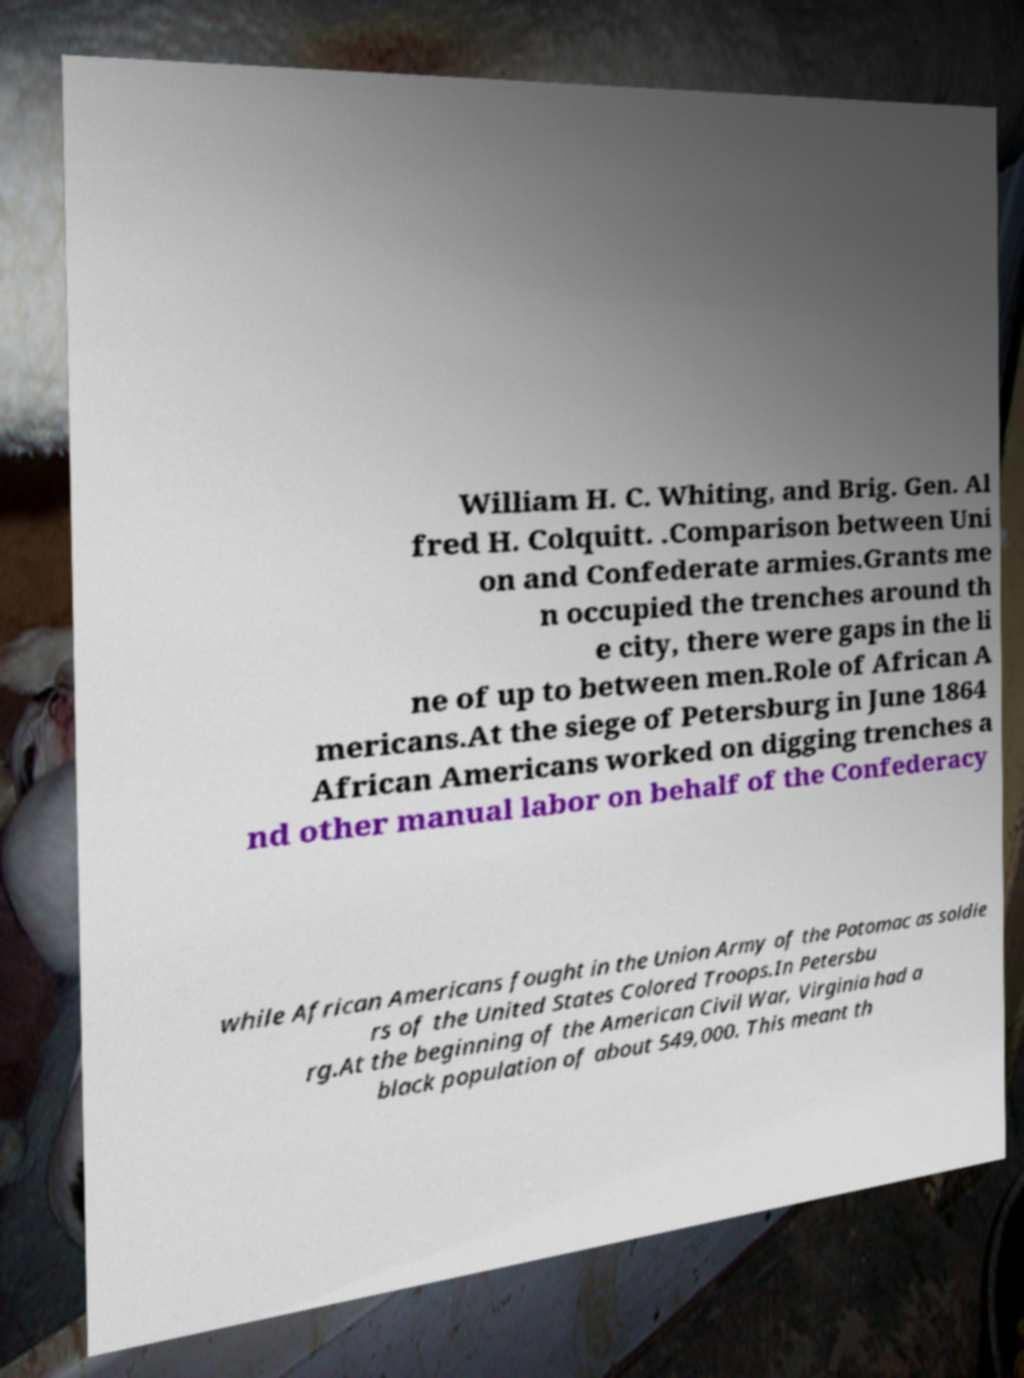There's text embedded in this image that I need extracted. Can you transcribe it verbatim? William H. C. Whiting, and Brig. Gen. Al fred H. Colquitt. .Comparison between Uni on and Confederate armies.Grants me n occupied the trenches around th e city, there were gaps in the li ne of up to between men.Role of African A mericans.At the siege of Petersburg in June 1864 African Americans worked on digging trenches a nd other manual labor on behalf of the Confederacy while African Americans fought in the Union Army of the Potomac as soldie rs of the United States Colored Troops.In Petersbu rg.At the beginning of the American Civil War, Virginia had a black population of about 549,000. This meant th 